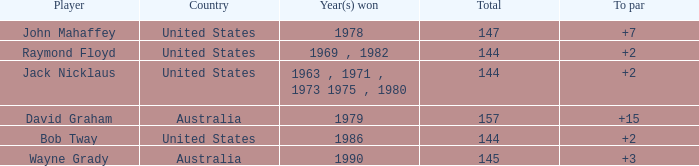How many strokes off par was the winner in 1978? 7.0. 